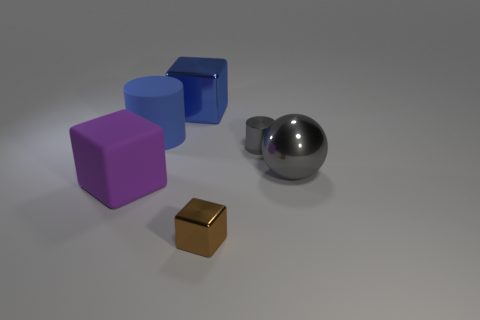Subtract all shiny cubes. How many cubes are left? 1 Add 1 tiny yellow matte cylinders. How many objects exist? 7 Subtract all cylinders. How many objects are left? 4 Subtract 0 green cylinders. How many objects are left? 6 Subtract all metallic cylinders. Subtract all gray cylinders. How many objects are left? 4 Add 2 shiny balls. How many shiny balls are left? 3 Add 5 cubes. How many cubes exist? 8 